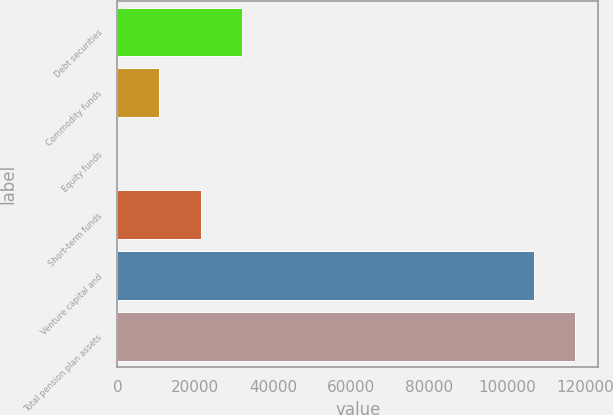<chart> <loc_0><loc_0><loc_500><loc_500><bar_chart><fcel>Debt securities<fcel>Commodity funds<fcel>Equity funds<fcel>Short-term funds<fcel>Venture capital and<fcel>Total pension plan assets<nl><fcel>32041.4<fcel>10681.5<fcel>1.53<fcel>21361.4<fcel>106801<fcel>117481<nl></chart> 